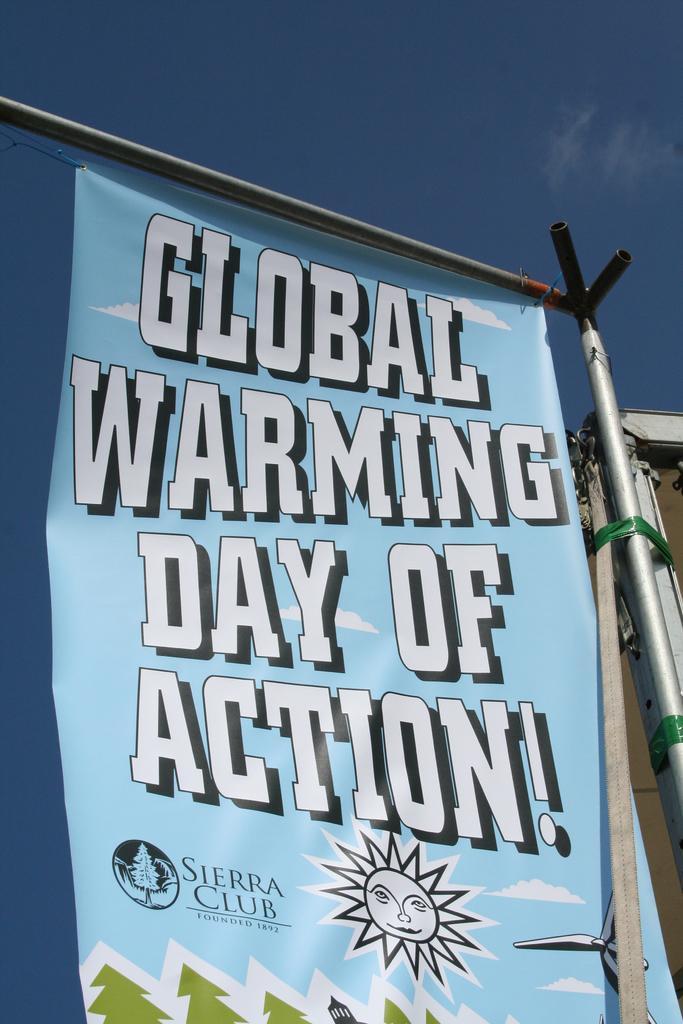Please provide a concise description of this image. This picture is clicked outside. In the center we can see the text and some pictures on the poster hanging on the metal rod. On the right corner we can see the metal rod and some other objects. In the background we can see the sky. 